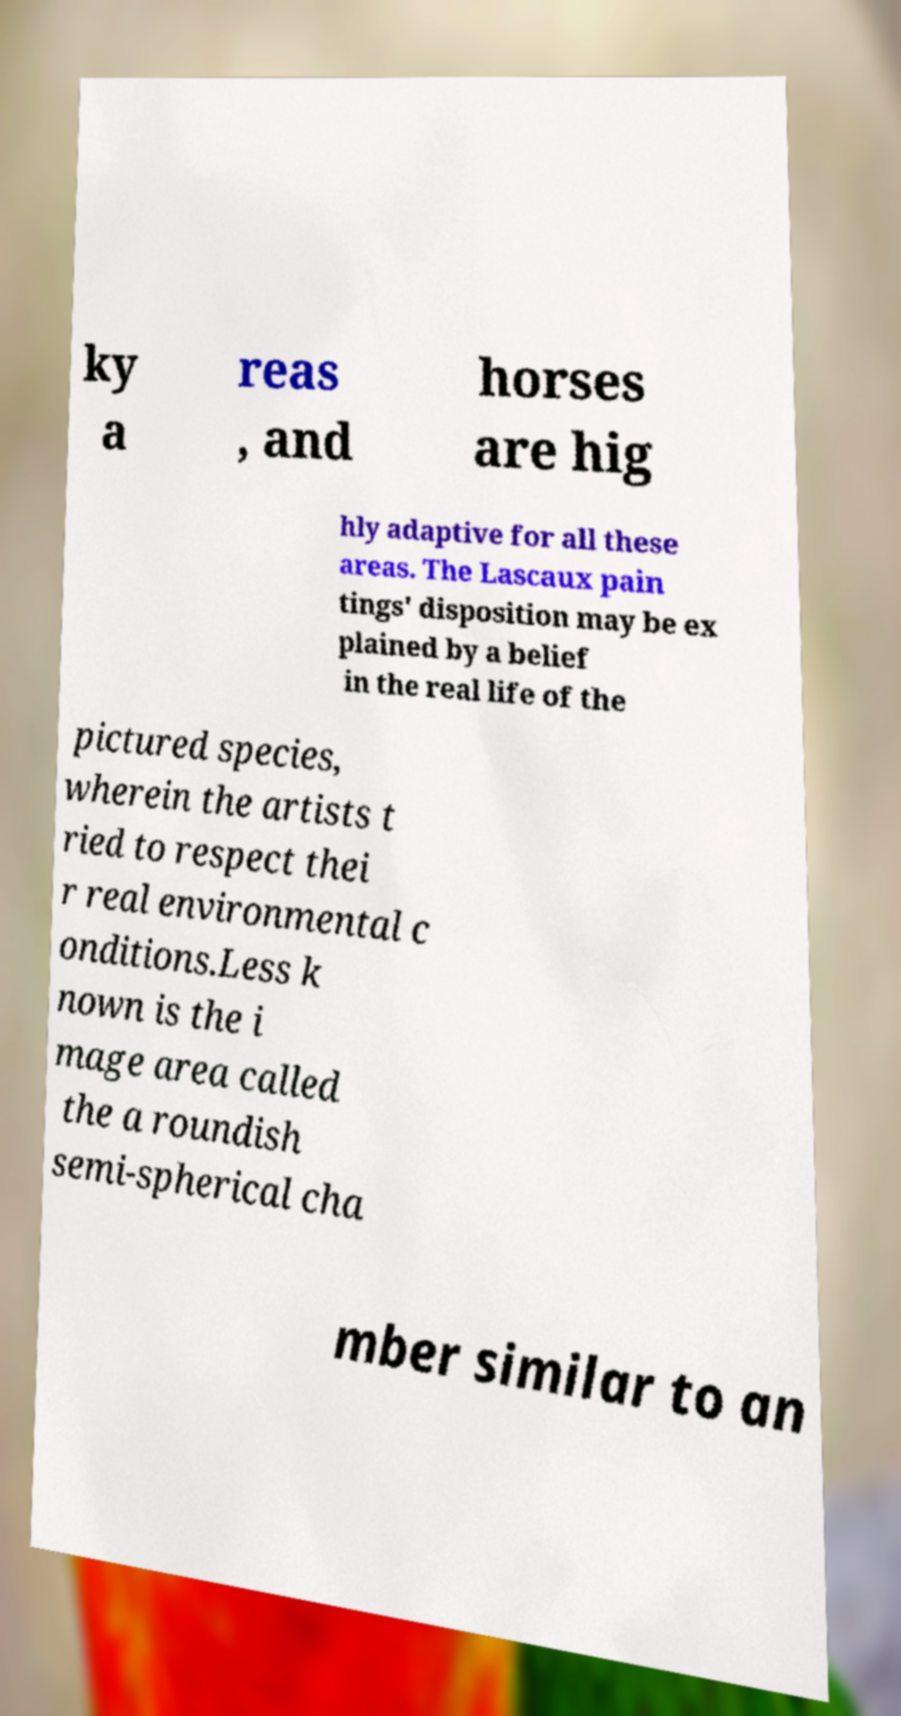Could you extract and type out the text from this image? ky a reas , and horses are hig hly adaptive for all these areas. The Lascaux pain tings' disposition may be ex plained by a belief in the real life of the pictured species, wherein the artists t ried to respect thei r real environmental c onditions.Less k nown is the i mage area called the a roundish semi-spherical cha mber similar to an 